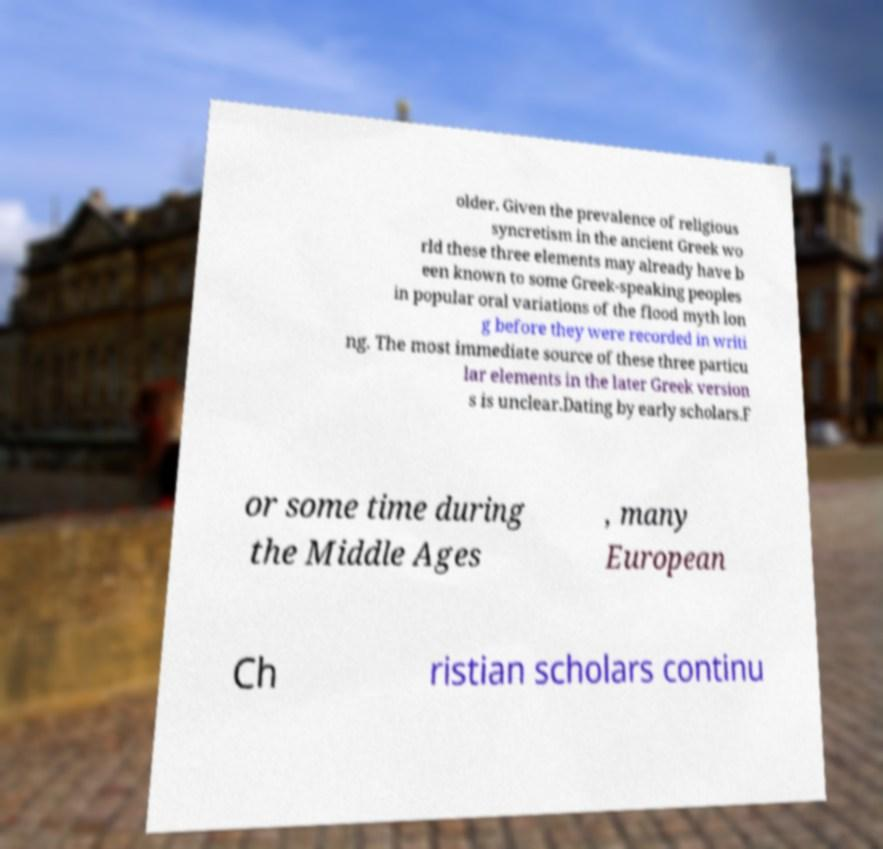Please read and relay the text visible in this image. What does it say? older. Given the prevalence of religious syncretism in the ancient Greek wo rld these three elements may already have b een known to some Greek-speaking peoples in popular oral variations of the flood myth lon g before they were recorded in writi ng. The most immediate source of these three particu lar elements in the later Greek version s is unclear.Dating by early scholars.F or some time during the Middle Ages , many European Ch ristian scholars continu 